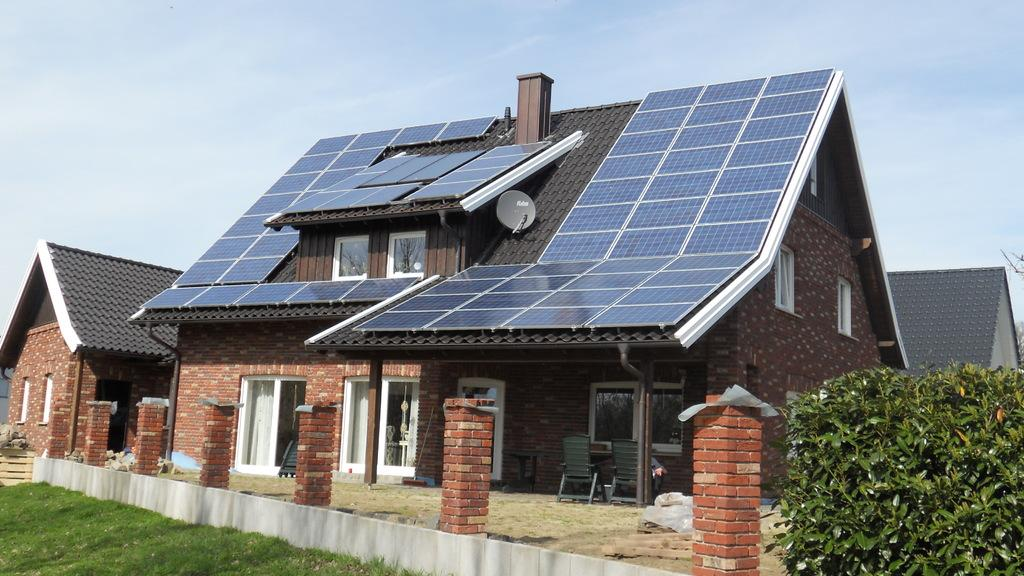What type of structures can be seen in the image? There are houses in the image. What features can be observed on the houses? The houses have windows. What objects are present in the image related to plumbing or utilities? There are pipes in the image. What type of furniture is visible in the image? There are chairs in the image. What type of vegetation is present in the image? There is grass in the image. What type of renewable energy source is visible in the image? There are solar panels in the image. What type of natural elements are present in the image? There are trees in the image. What is visible in the background of the image? The sky is visible in the background of the image. What weather condition can be inferred from the sky? There are clouds in the sky, suggesting a partly cloudy day. Where is the tray located in the image? There is no tray present in the image. What type of toy is visible in the image? There are no toys visible in the image. 